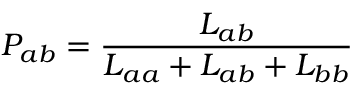<formula> <loc_0><loc_0><loc_500><loc_500>P _ { a b } = \frac { L _ { a b } } { L _ { a a } + L _ { a b } + L _ { b b } }</formula> 